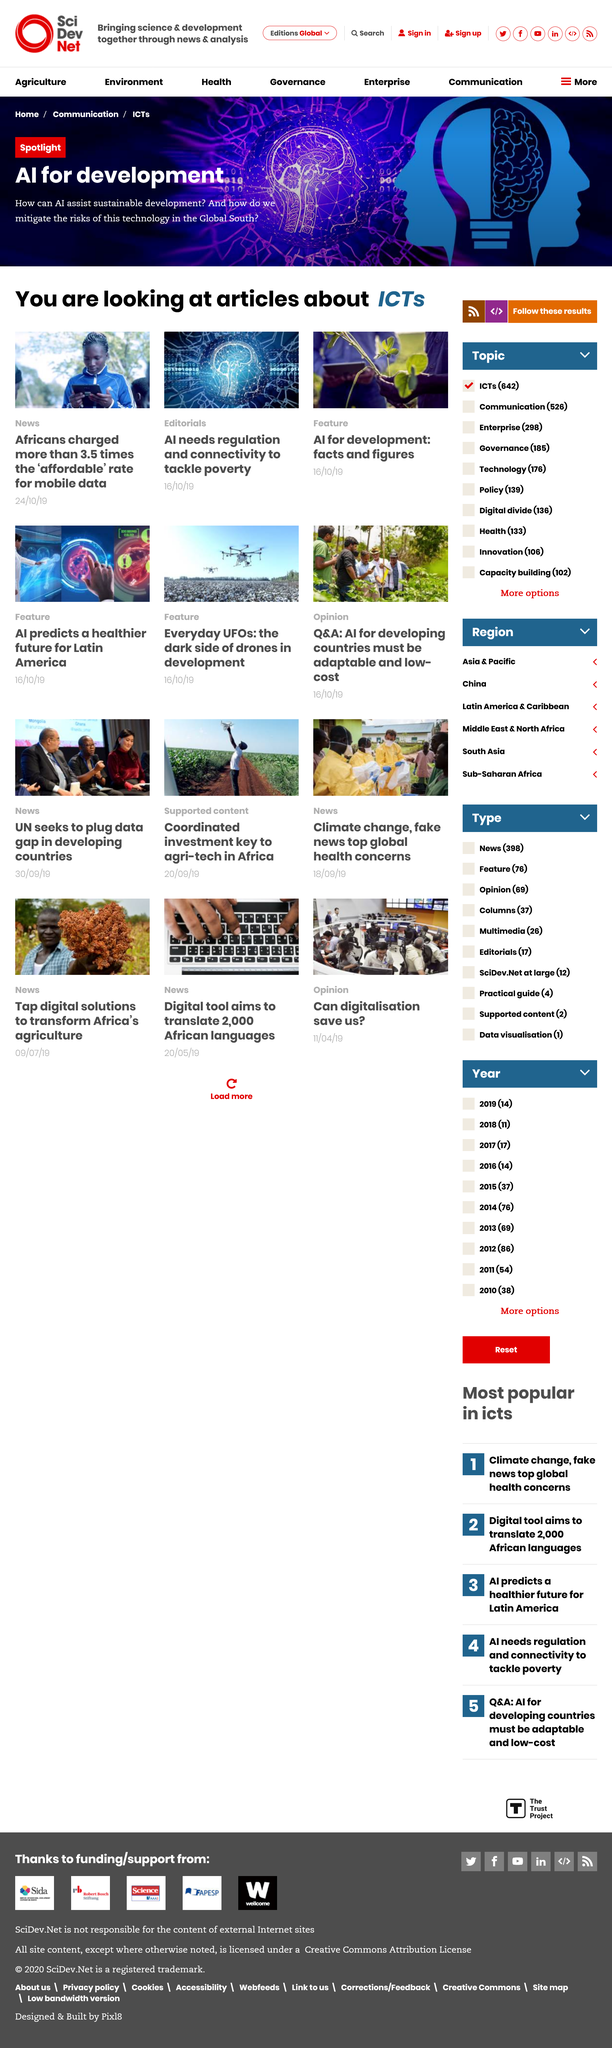List a handful of essential elements in this visual. The feature article "AI for development: facts and figures" was published on October 16, 2022. Africans are charged more than three and a half times the affordable rate for mobile data. The article titled 'AI needs regulation and connectivity to tackle poverty' was published on October 16, 2019. 